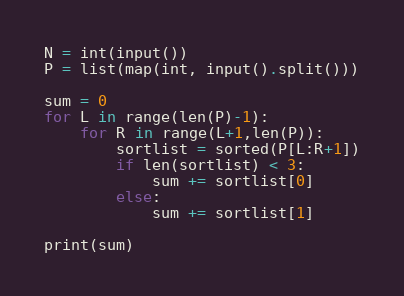<code> <loc_0><loc_0><loc_500><loc_500><_Python_>N = int(input())
P = list(map(int, input().split()))

sum = 0
for L in range(len(P)-1):
    for R in range(L+1,len(P)):
        sortlist = sorted(P[L:R+1])
        if len(sortlist) < 3:
            sum += sortlist[0]
        else:
            sum += sortlist[1]

print(sum)</code> 